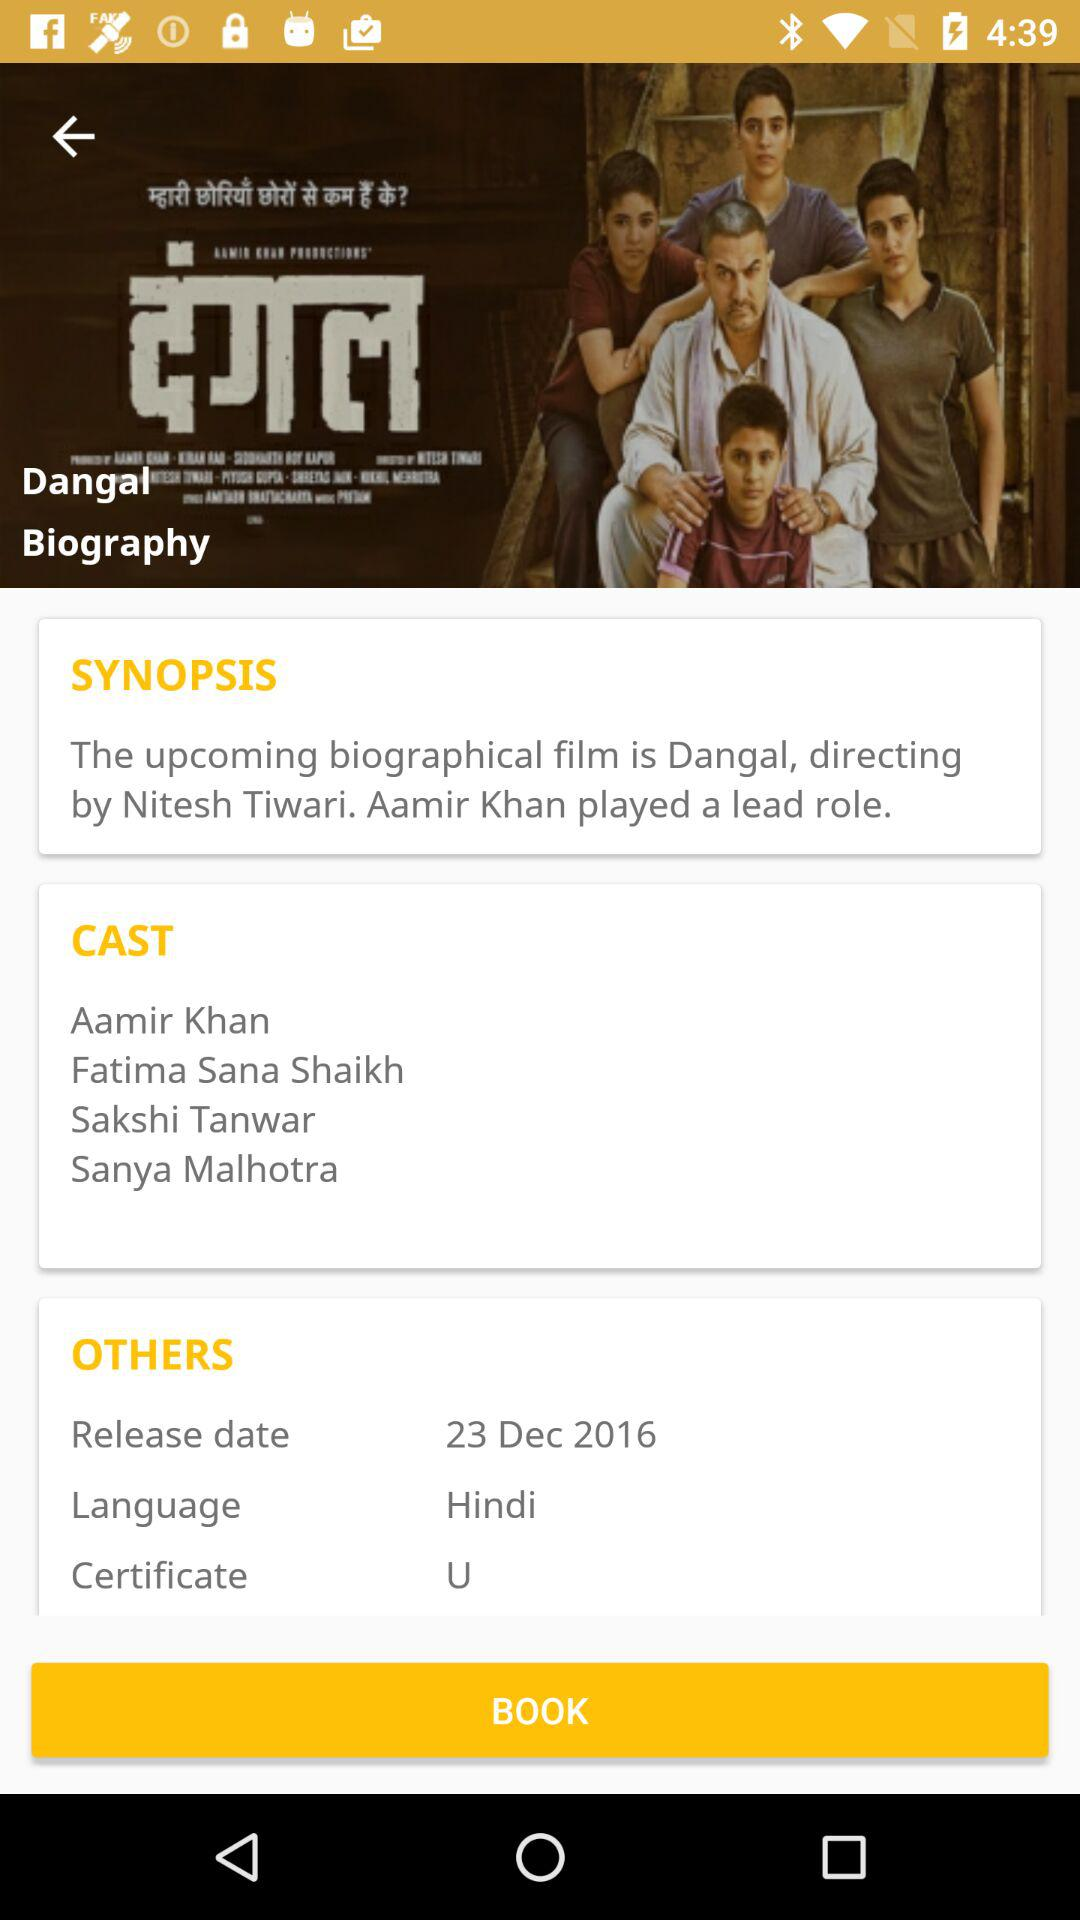What is the language of the movie? The language of the movie is Hindi. 